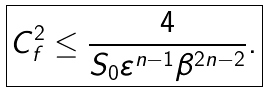Convert formula to latex. <formula><loc_0><loc_0><loc_500><loc_500>\boxed { C _ { f } ^ { 2 } \leq \frac { 4 } { S _ { 0 } \varepsilon ^ { n - 1 } \beta ^ { 2 n - 2 } } . }</formula> 